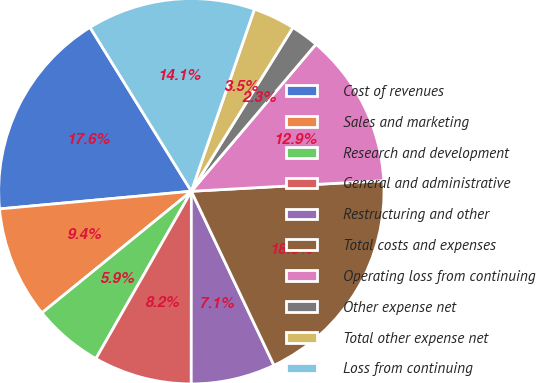Convert chart. <chart><loc_0><loc_0><loc_500><loc_500><pie_chart><fcel>Cost of revenues<fcel>Sales and marketing<fcel>Research and development<fcel>General and administrative<fcel>Restructuring and other<fcel>Total costs and expenses<fcel>Operating loss from continuing<fcel>Other expense net<fcel>Total other expense net<fcel>Loss from continuing<nl><fcel>17.65%<fcel>9.41%<fcel>5.88%<fcel>8.24%<fcel>7.06%<fcel>18.82%<fcel>12.94%<fcel>2.35%<fcel>3.53%<fcel>14.12%<nl></chart> 